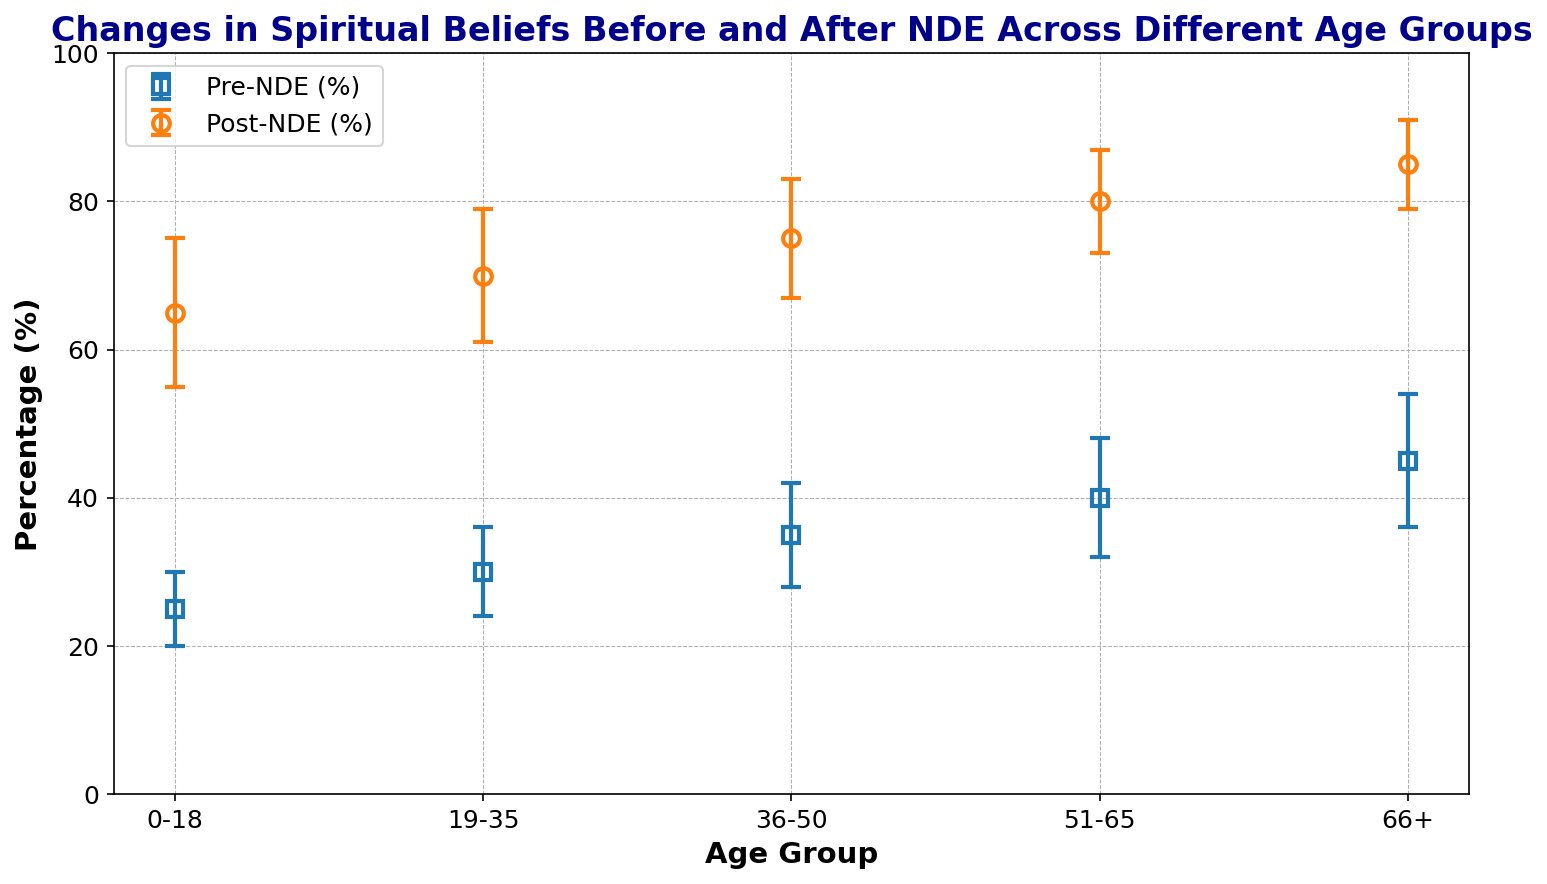What is the percentage change in spiritual beliefs for the age group 19-35 after a near-death experience? To find the percentage change, subtract the pre-NDE percentage from the post-NDE percentage for the age group 19-35. Calculation: 70% (Post-NDE) - 30% (Pre-NDE)
Answer: 40% Which age group shows the highest increase in spiritual beliefs after a near-death experience? Compare the increase in percentage of spiritual beliefs for all age groups by subtracting pre-NDE values from post-NDE values for each age group. The highest increase can be identified from these differences.
Answer: 66+ How does the standard deviation for the age group 36-50 compare before and after the near-death experience? Compare the standard deviation values for pre-NDE (7) and post-NDE (8) for the age group 36-50. The standard deviation after the NDE is slightly higher.
Answer: Higher after NDE For which age group is the standard deviation the smallest for post-NDE percentages? Review the standard deviation values for post-NDE percentages across all age groups and identify the smallest value.
Answer: 66+ By how much do the spiritual beliefs of the youngest age group (0-18) increase after a near-death experience? Subtract the pre-NDE percentage (25%) from the post-NDE percentage (65%) for the age group 0-18. Calculation: 65% - 25% = 40%
Answer: 40% Which age group has the highest pre-NDE spiritual belief percentage? Identify the highest percentage value among pre-NDE percentages for all age groups by comparing the pre-NDE values.
Answer: 66+ Is the increase in spiritual beliefs for the age group 51-65 greater than the increase for the age group 36-50? Compare the increase for both age groups: 51-65 (80% - 40% = 40%) and 36-50 (75% - 35% = 40%). Both have an increase of 40%.
Answer: No What is the average post-NDE spiritual belief percentage for the age groups 19-35 and 66+? Calculate the average of post-NDE percentages for the age groups 19-35 (70%) and 66+ (85%). Calculation: (70% + 85%) / 2 = 77.5%
Answer: 77.5% Which age group shows the smallest standard deviation before the near-death experience? Identify the smallest standard deviation value for pre-NDE percentages from the data.
Answer: 0-18 